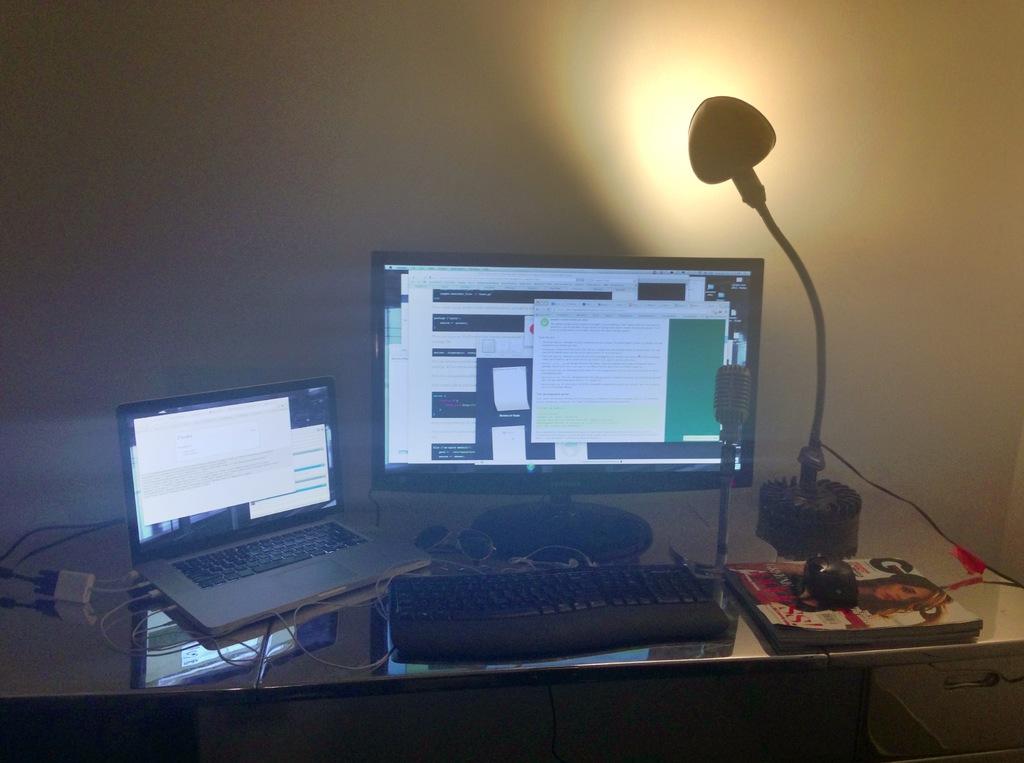Is the mousepad actually a magazine?
Offer a very short reply. Answering does not require reading text in the image. 